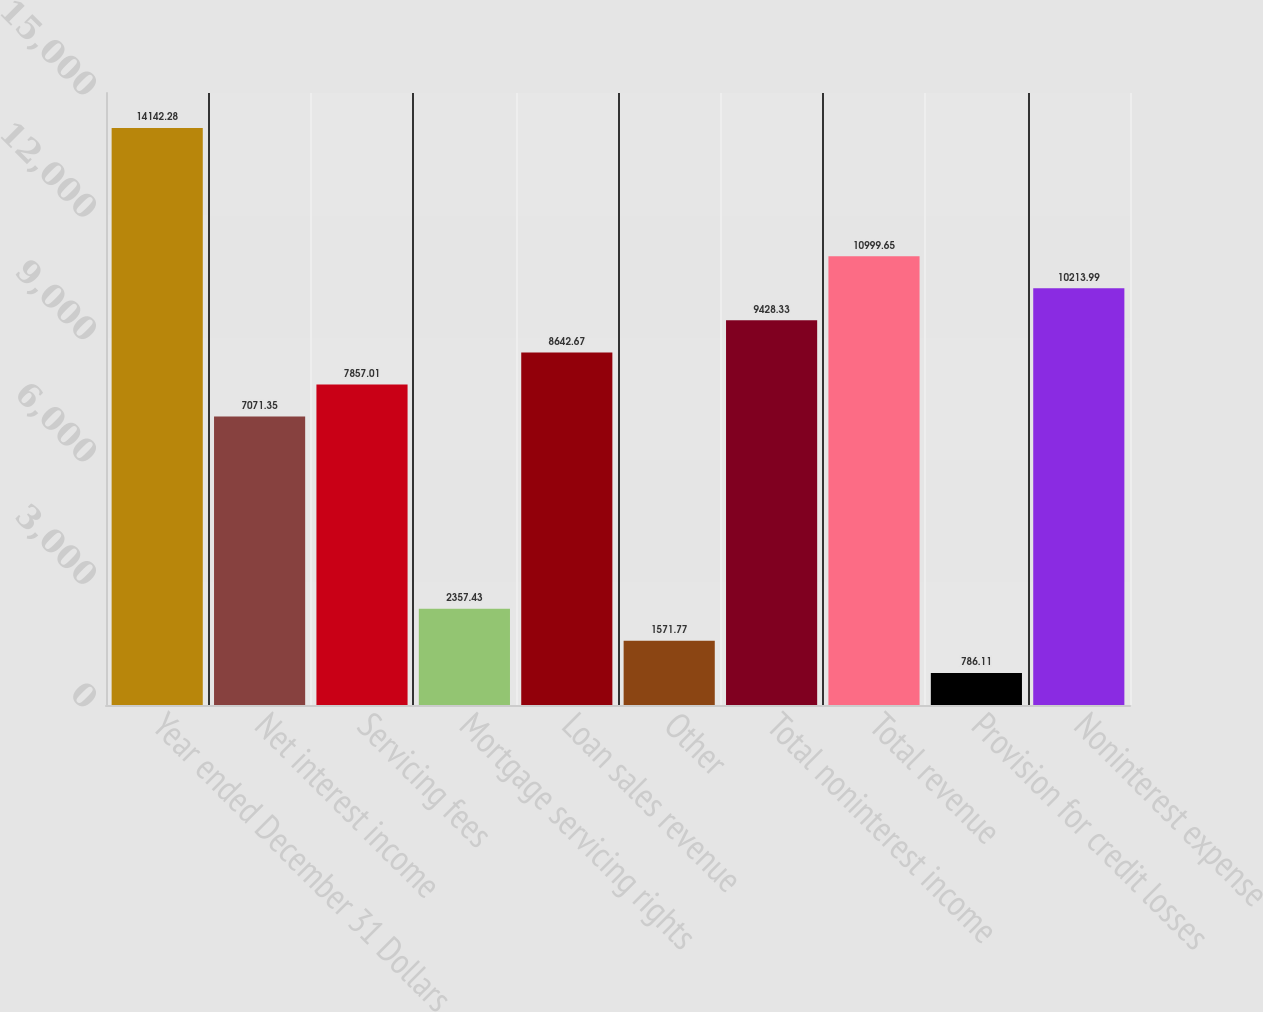<chart> <loc_0><loc_0><loc_500><loc_500><bar_chart><fcel>Year ended December 31 Dollars<fcel>Net interest income<fcel>Servicing fees<fcel>Mortgage servicing rights<fcel>Loan sales revenue<fcel>Other<fcel>Total noninterest income<fcel>Total revenue<fcel>Provision for credit losses<fcel>Noninterest expense<nl><fcel>14142.3<fcel>7071.35<fcel>7857.01<fcel>2357.43<fcel>8642.67<fcel>1571.77<fcel>9428.33<fcel>10999.6<fcel>786.11<fcel>10214<nl></chart> 